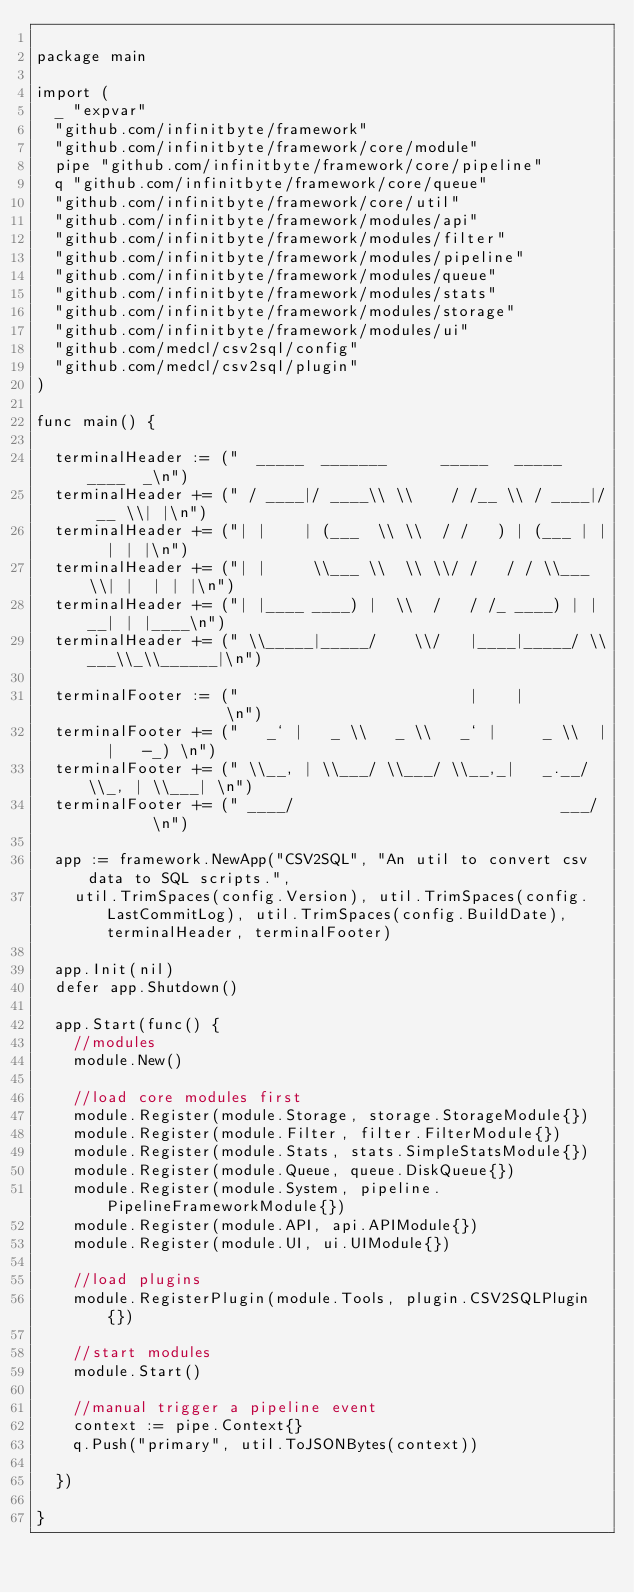Convert code to text. <code><loc_0><loc_0><loc_500><loc_500><_Go_>
package main

import (
	_ "expvar"
	"github.com/infinitbyte/framework"
	"github.com/infinitbyte/framework/core/module"
	pipe "github.com/infinitbyte/framework/core/pipeline"
	q "github.com/infinitbyte/framework/core/queue"
	"github.com/infinitbyte/framework/core/util"
	"github.com/infinitbyte/framework/modules/api"
	"github.com/infinitbyte/framework/modules/filter"
	"github.com/infinitbyte/framework/modules/pipeline"
	"github.com/infinitbyte/framework/modules/queue"
	"github.com/infinitbyte/framework/modules/stats"
	"github.com/infinitbyte/framework/modules/storage"
	"github.com/infinitbyte/framework/modules/ui"
	"github.com/medcl/csv2sql/config"
	"github.com/medcl/csv2sql/plugin"
)

func main() {

	terminalHeader := ("  _____  _______      _____   _____  ____  _\n")
	terminalHeader += (" / ____|/ ____\\ \\    / /__ \\ / ____|/ __ \\| |\n")
	terminalHeader += ("| |    | (___  \\ \\  / /   ) | (___ | |  | | |\n")
	terminalHeader += ("| |     \\___ \\  \\ \\/ /   / / \\___ \\| |  | | |\n")
	terminalHeader += ("| |____ ____) |  \\  /   / /_ ____) | |__| | |____\n")
	terminalHeader += (" \\_____|_____/    \\/   |____|_____/ \\___\\_\\______|\n")

	terminalFooter := ("                         |    |                \n")
	terminalFooter += ("   _` |   _ \\   _ \\   _` |     _ \\  |  |   -_) \n")
	terminalFooter += (" \\__, | \\___/ \\___/ \\__,_|   _.__/ \\_, | \\___| \n")
	terminalFooter += (" ____/                             ___/        \n")

	app := framework.NewApp("CSV2SQL", "An util to convert csv data to SQL scripts.",
		util.TrimSpaces(config.Version), util.TrimSpaces(config.LastCommitLog), util.TrimSpaces(config.BuildDate), terminalHeader, terminalFooter)

	app.Init(nil)
	defer app.Shutdown()

	app.Start(func() {
		//modules
		module.New()

		//load core modules first
		module.Register(module.Storage, storage.StorageModule{})
		module.Register(module.Filter, filter.FilterModule{})
		module.Register(module.Stats, stats.SimpleStatsModule{})
		module.Register(module.Queue, queue.DiskQueue{})
		module.Register(module.System, pipeline.PipelineFrameworkModule{})
		module.Register(module.API, api.APIModule{})
		module.Register(module.UI, ui.UIModule{})

		//load plugins
		module.RegisterPlugin(module.Tools, plugin.CSV2SQLPlugin{})

		//start modules
		module.Start()

		//manual trigger a pipeline event
		context := pipe.Context{}
		q.Push("primary", util.ToJSONBytes(context))

	})

}
</code> 